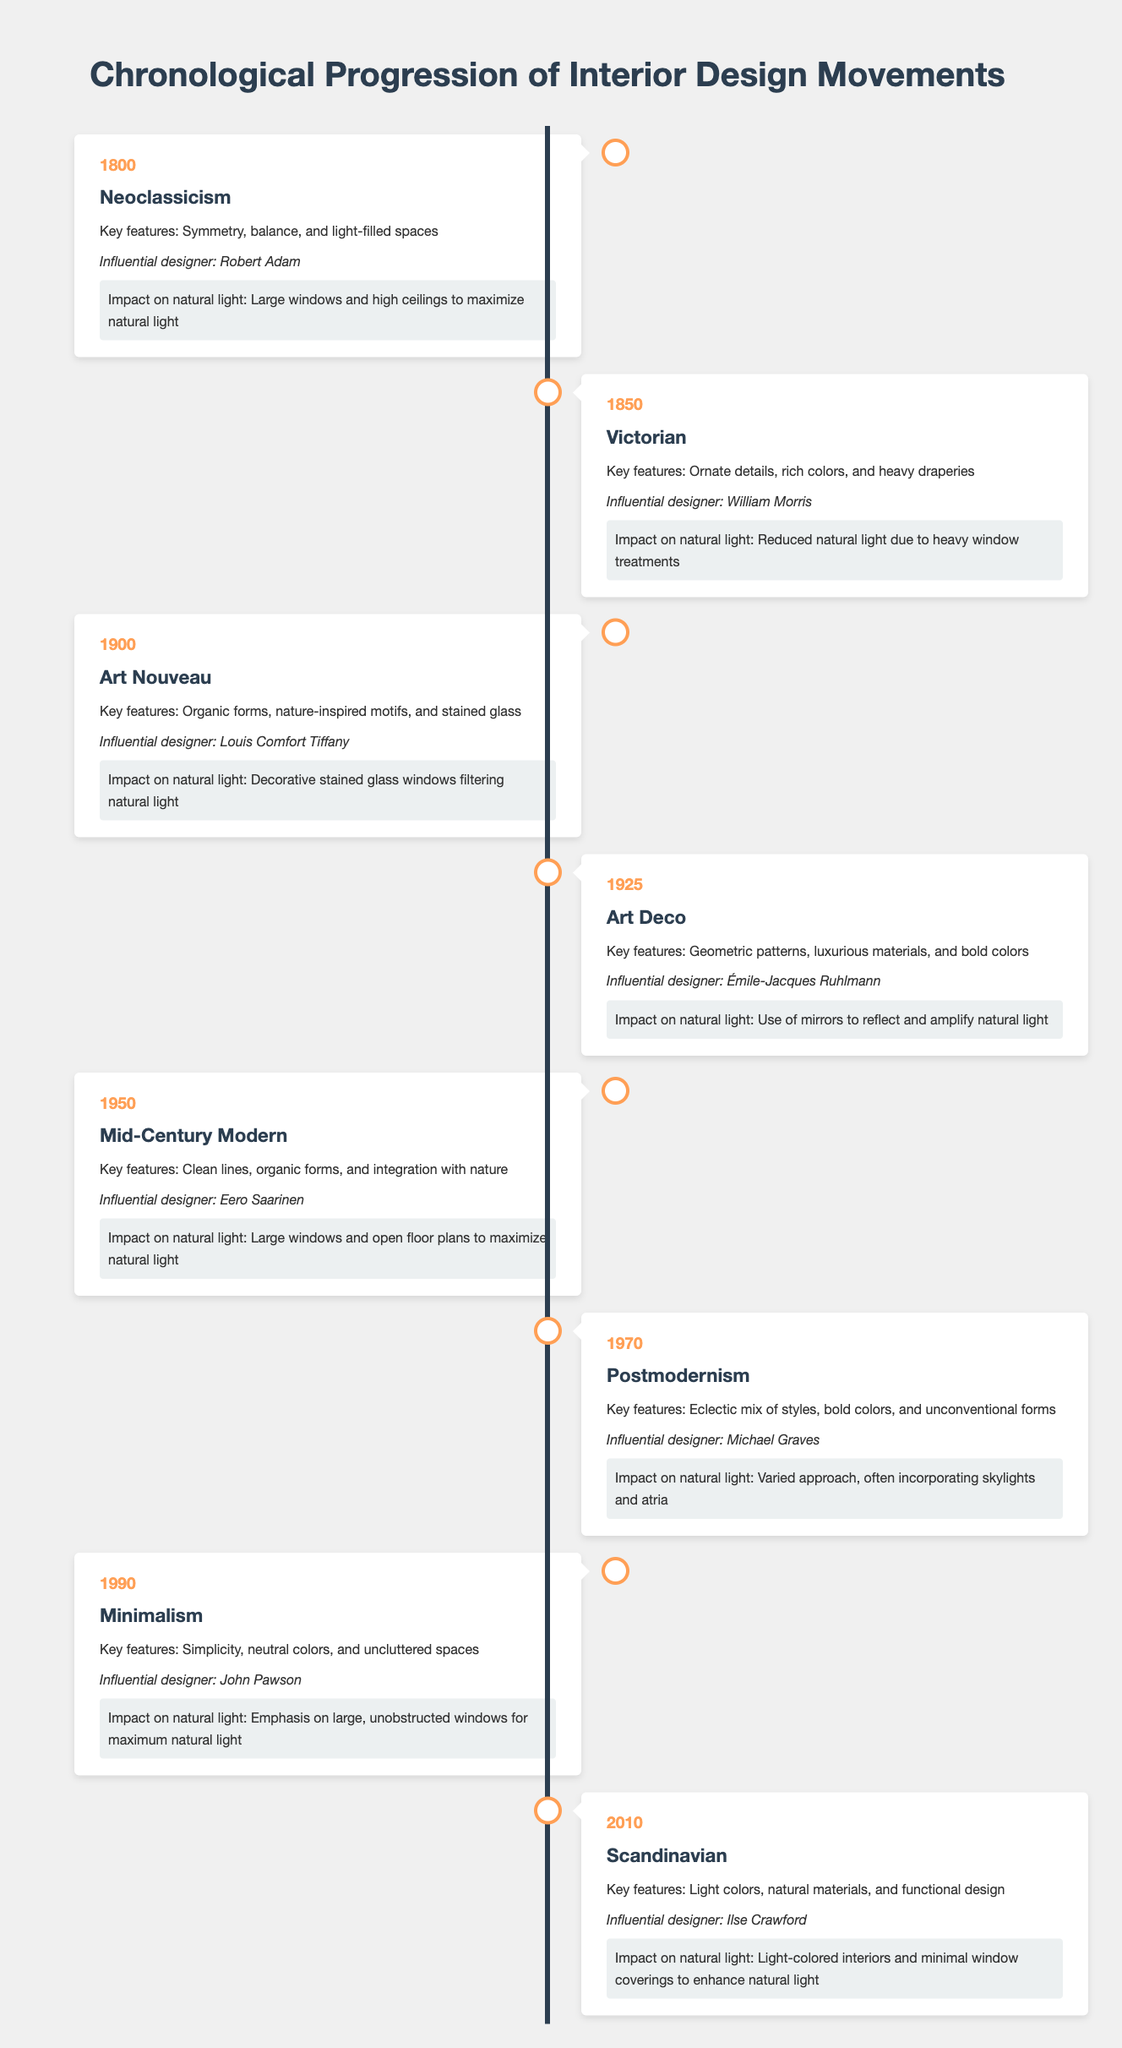What year did the Mid-Century Modern movement occur? According to the timeline, the Mid-Century Modern movement took place in 1950.
Answer: 1950 Which influential designer is associated with the Art Nouveau movement? The timeline indicates that Louis Comfort Tiffany is the influential designer associated with the Art Nouveau movement, which occurred in 1900.
Answer: Louis Comfort Tiffany Was natural light emphasized in Neoclassicism? Yes, the data shows that the Neoclassicism movement focused on large windows and high ceilings to maximize natural light.
Answer: Yes What is the key feature of the Minimalism movement? The timeline states that the key features of the Minimalism movement include simplicity, neutral colors, and uncluttered spaces.
Answer: Simplicity, neutral colors, and uncluttered spaces How does the impact of natural light differ between Victorian and Neoclassicism movements? The Victorian movement reduced natural light due to heavy window treatments, whereas Neoclassicism maximized it with large windows and high ceilings, showcasing a distinct contrast between their approaches towards natural light.
Answer: Victorian reduces light; Neoclassicism maximizes light What was the primary approach towards natural light during the Postmodernism movement? The timeline indicates that Postmodernism incorporated a varied approach to natural light, often including skylights and atria, allowing for different ways of enhancing interior light.
Answer: Incorporates skylights and atria Which interior design movement prioritized the use of mirrors, and what effect did this have on natural light? The Art Deco movement prioritized the use of mirrors to reflect and amplify natural light, enhancing the overall brightness in a space.
Answer: Art Deco; amplifies natural light List the movements that emphasized large windows for natural light and count them. The movements emphasizing large windows for natural light are Neoclassicism (1800), Mid-Century Modern (1950), and Minimalism (1990). There are three movements in total that focused on this aspect.
Answer: Three movements What change occurred in the approach to natural light around 2010 compared to the Victorian era? Around 2010, the Scandinavian movement focused on light-colored interiors and minimal window coverings to enhance natural light, in stark contrast to the Victorian era, which reduced natural light due to heavy window treatments, indicating an evolution toward maximizing light in interior design.
Answer: Evolution toward maximizing light 